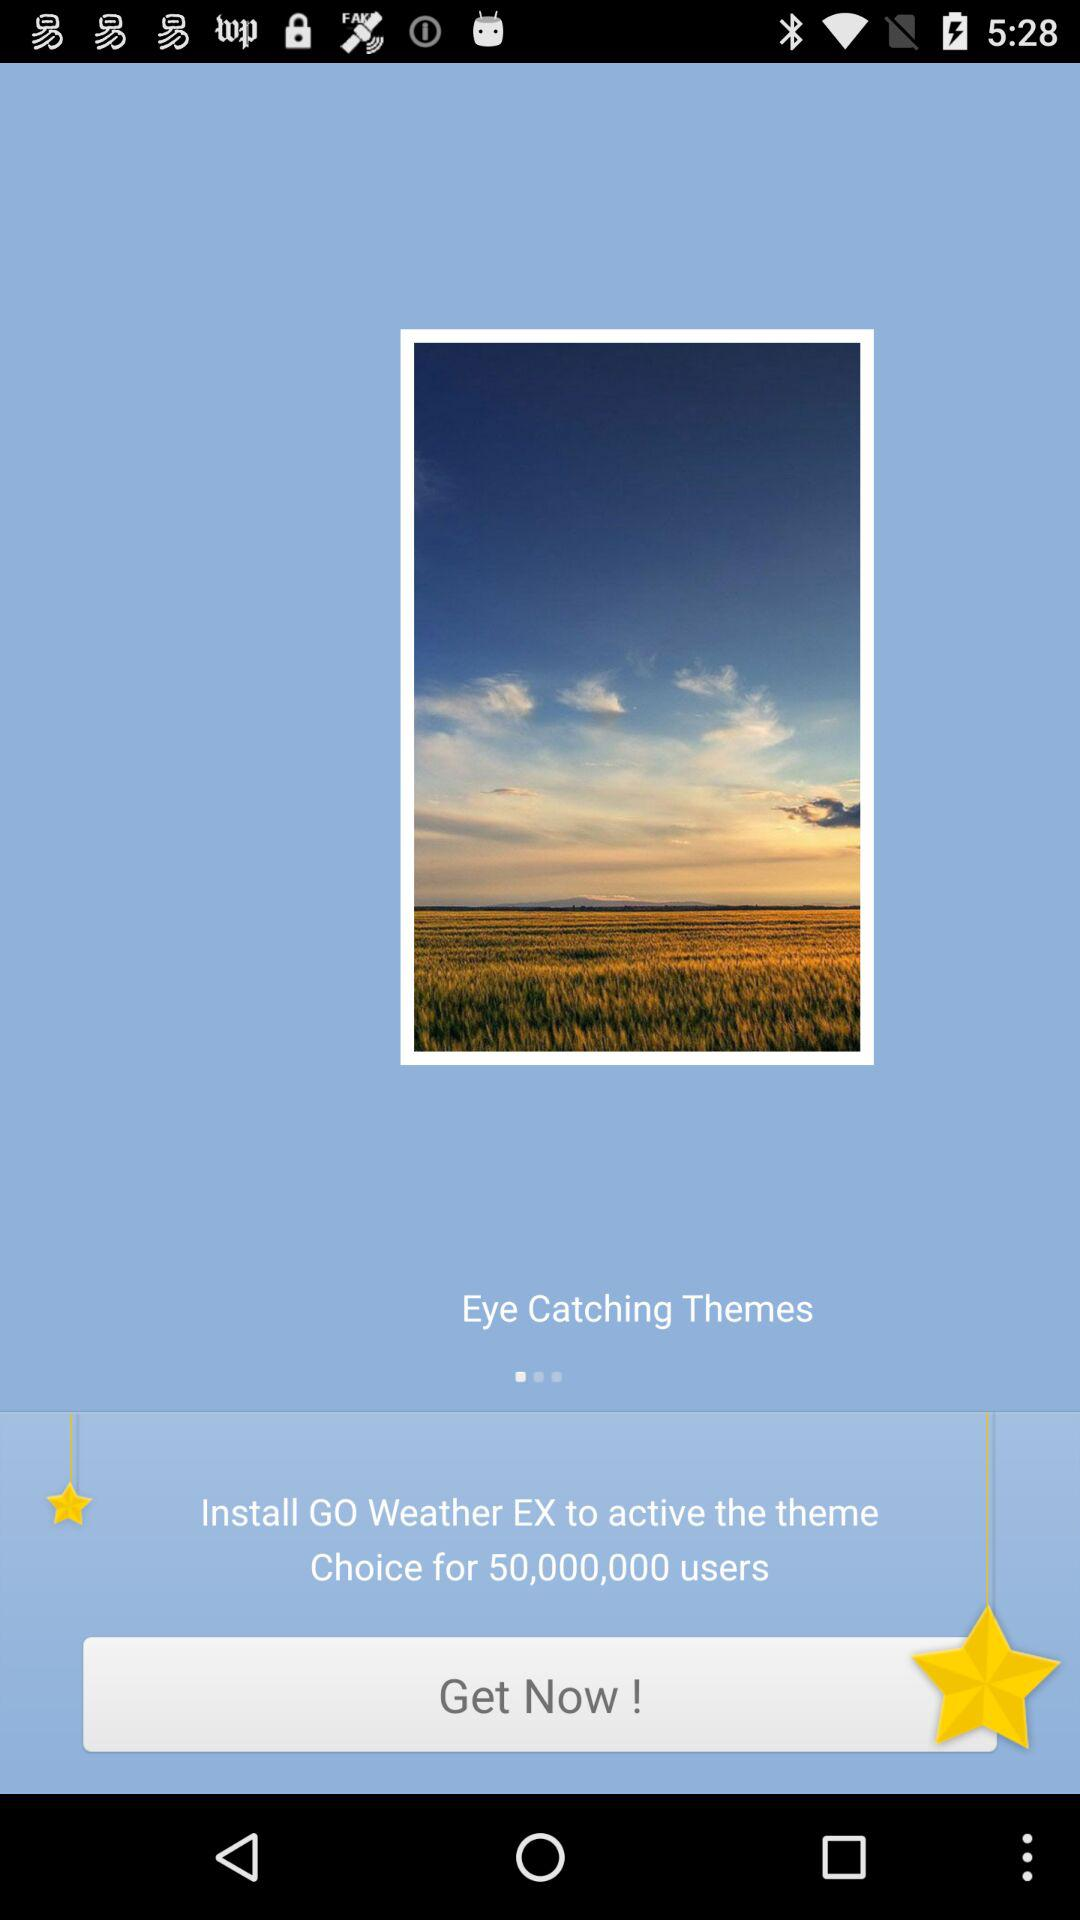For how many users is the application "GO Weather EX" a choice? There are 50 million users. 